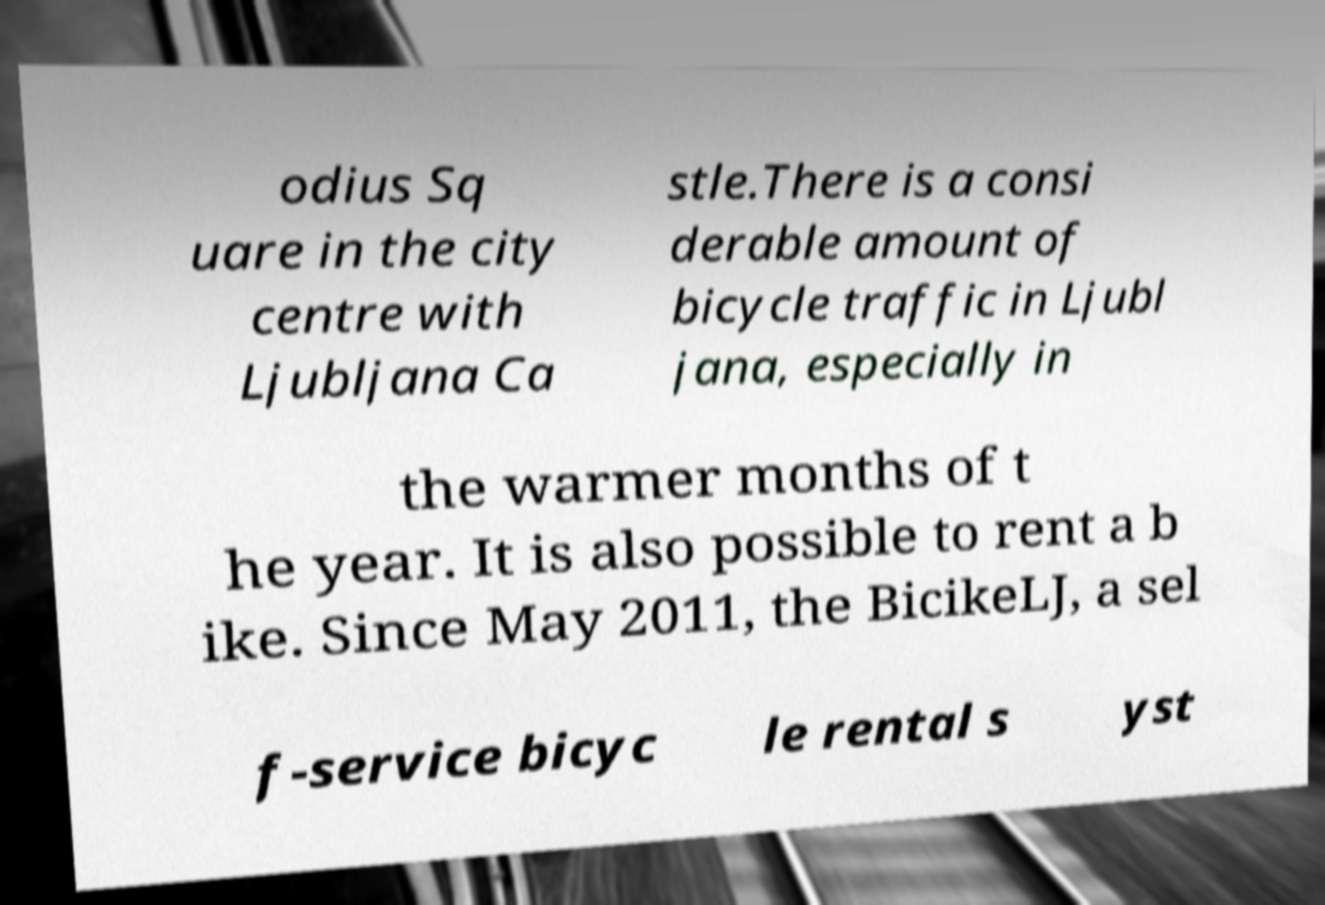Please identify and transcribe the text found in this image. odius Sq uare in the city centre with Ljubljana Ca stle.There is a consi derable amount of bicycle traffic in Ljubl jana, especially in the warmer months of t he year. It is also possible to rent a b ike. Since May 2011, the BicikeLJ, a sel f-service bicyc le rental s yst 